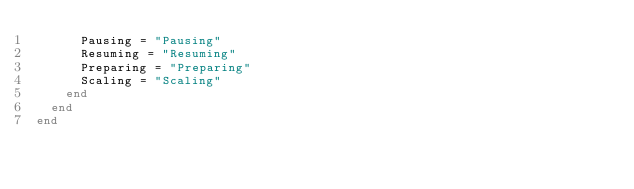Convert code to text. <code><loc_0><loc_0><loc_500><loc_500><_Ruby_>      Pausing = "Pausing"
      Resuming = "Resuming"
      Preparing = "Preparing"
      Scaling = "Scaling"
    end
  end
end
</code> 